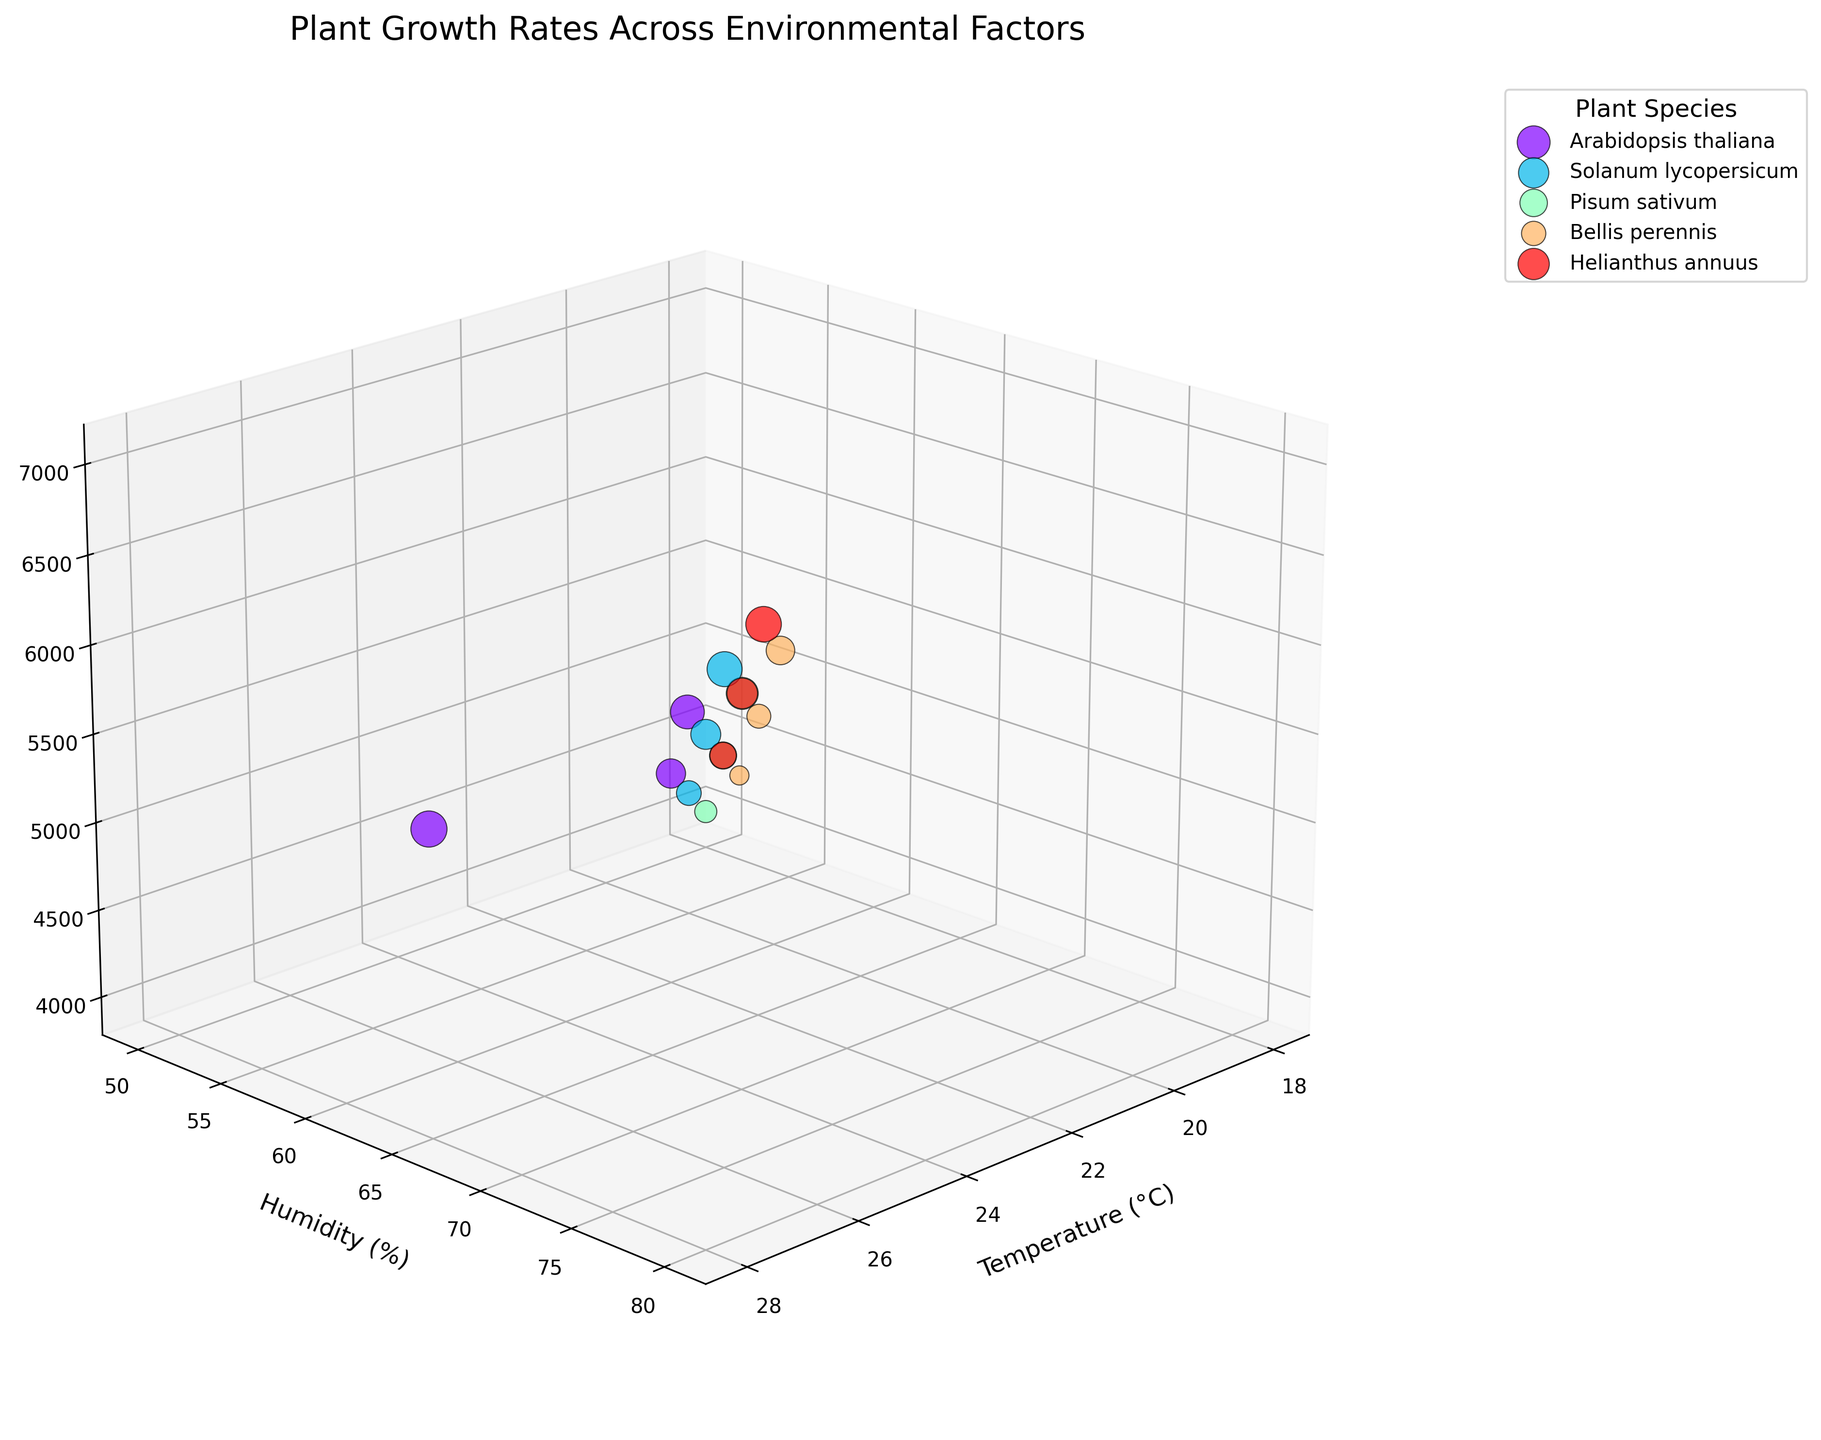What is the title of the figure? The title is usually located at the top of the figure. In this case, the title reads "Plant Growth Rates Across Environmental Factors."
Answer: Plant Growth Rates Across Environmental Factors What does the color of the points represent? The color of the points represents different plant species. Each species is assigned a unique color for differentiation.
Answer: Plant species How many species are represented in the figure? By checking the legend of the figure, we can see that there are 5 unique plant species listed.
Answer: 5 Which axis represents the Humidity (%)? The y-axis represents the Humidity (%), as indicated by the axis label.
Answer: y-axis Which species has data points with the highest growth rate, and what is the approximate value? By looking at the size of the points, we see that "Helianthus annuus" features the largest points, indicating the highest growth rate, which appears to be around 3.1.
Answer: Helianthus annuus, approx. 3.1 Which species shows the lowest growth rate? By identifying the smallest data points visually, "Bellis perennis" shows the smallest, indicating the lowest growth rate, which appears to be around 0.9.
Answer: Bellis perennis For Arabidopsis thaliana, does an increase in temperature generally correlate with an increase in growth rate? By observing the pattern of the points for Arabidopsis thaliana and noting the axis values, as temperature increases, the growth rate also appears to increase.
Answer: Yes What is the range of light intensity values covered in this dataset? From the light intensity axis (z-axis), we can see the lowest value is 4000 lux and the highest value is 7000 lux.
Answer: 4000 to 7000 lux Which plant species seems to thrive best at higher levels of humidity and light intensity? By observing the distribution of points, Solanum lycopersicum shows higher growth rates at higher values of both humidity and light intensity.
Answer: Solanum lycopersicum Do Pisum sativum and Bellis perennis have overlapping points, and if so, under what environmental conditions? By visually examining their points, some of their points overlap, specifically around 21-22°C temperature and 60-65% humidity with light intensity around 5000-5500 lux.
Answer: Yes, around 21-22°C temperature, 60-65% humidity, and 5000-5500 lux 